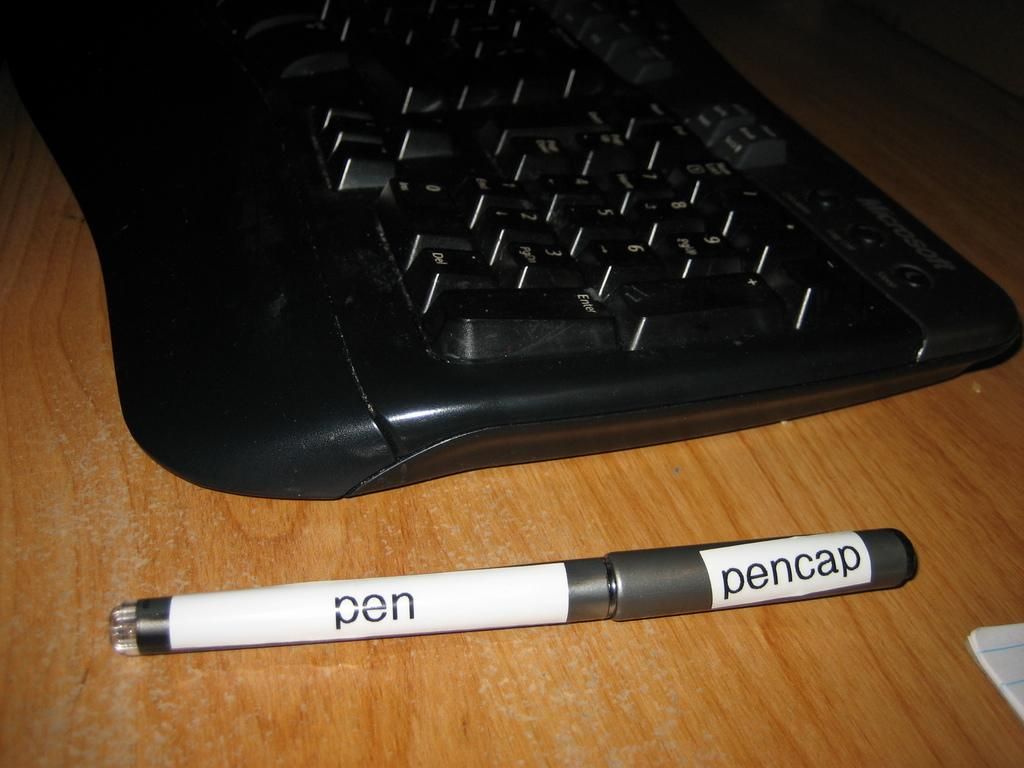Provide a one-sentence caption for the provided image. A pen sitting next to a keyboard is labeled with pen and pencap. 